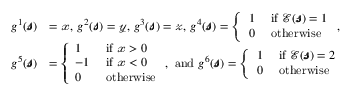<formula> <loc_0><loc_0><loc_500><loc_500>\begin{array} { r l } { g ^ { 1 } ( \pm b { \ m a t h s c r { s } } ) } & { = \ m a t h s c r { x } , g ^ { 2 } ( \pm b { \ m a t h s c r { s } } ) = \ m a t h s c r { y } , g ^ { 3 } ( \pm b { \ m a t h s c r { s } } ) = \ m a t h s c r { z } , g ^ { 4 } ( \pm b { \ m a t h s c r { s } } ) = \left \{ \begin{array} { l l } { 1 } & { i f \mathcal { E } ( \pm b { \ m a t h s c r { s } } ) = 1 } \\ { 0 } & { o t h e r w i s e } \end{array} , } \\ { g ^ { 5 } ( \pm b { \ m a t h s c r { s } } ) } & { = \left \{ \begin{array} { l l } { 1 } & { i f \ m a t h s c r { x } > 0 } \\ { - 1 } & { i f \ m a t h s c r { x } < 0 } \\ { 0 } & { o t h e r w i s e } \end{array} , a n d g ^ { 6 } ( \pm b { \ m a t h s c r { s } } ) = \left \{ \begin{array} { l l } { 1 } & { i f \mathcal { E } ( \pm b { \ m a t h s c r { s } } ) = 2 } \\ { 0 } & { o t h e r w i s e } \end{array} } \end{array}</formula> 